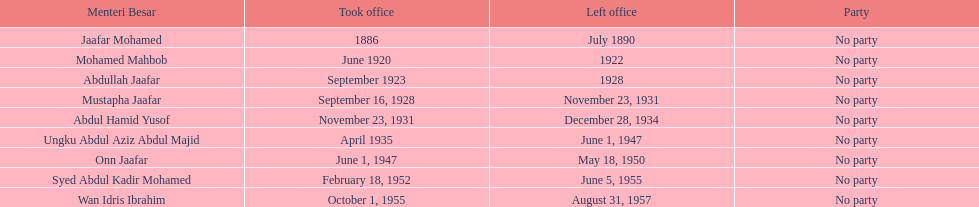Who spend the most amount of time in office? Ungku Abdul Aziz Abdul Majid. 